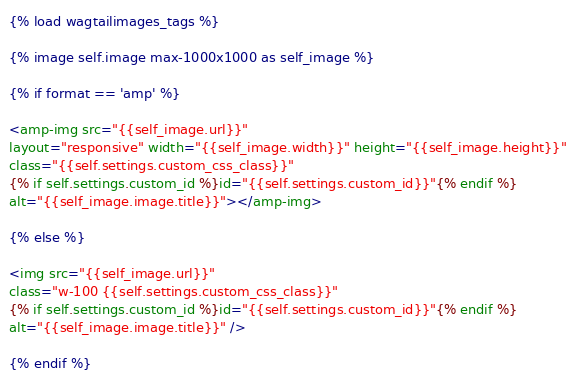Convert code to text. <code><loc_0><loc_0><loc_500><loc_500><_HTML_>{% load wagtailimages_tags %}

{% image self.image max-1000x1000 as self_image %}

{% if format == 'amp' %}

<amp-img src="{{self_image.url}}"
layout="responsive" width="{{self_image.width}}" height="{{self_image.height}}"
class="{{self.settings.custom_css_class}}"
{% if self.settings.custom_id %}id="{{self.settings.custom_id}}"{% endif %}
alt="{{self_image.image.title}}"></amp-img>

{% else %}

<img src="{{self_image.url}}"
class="w-100 {{self.settings.custom_css_class}}"
{% if self.settings.custom_id %}id="{{self.settings.custom_id}}"{% endif %}
alt="{{self_image.image.title}}" />

{% endif %}</code> 